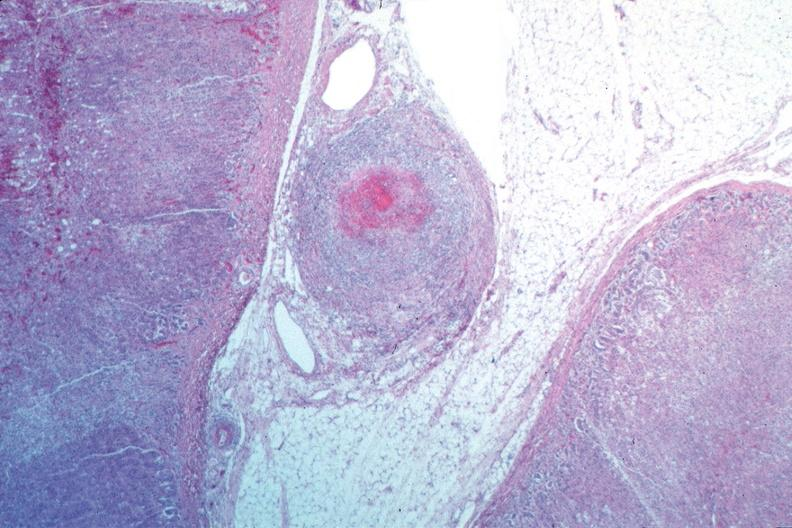where is this from?
Answer the question using a single word or phrase. Vasculature 